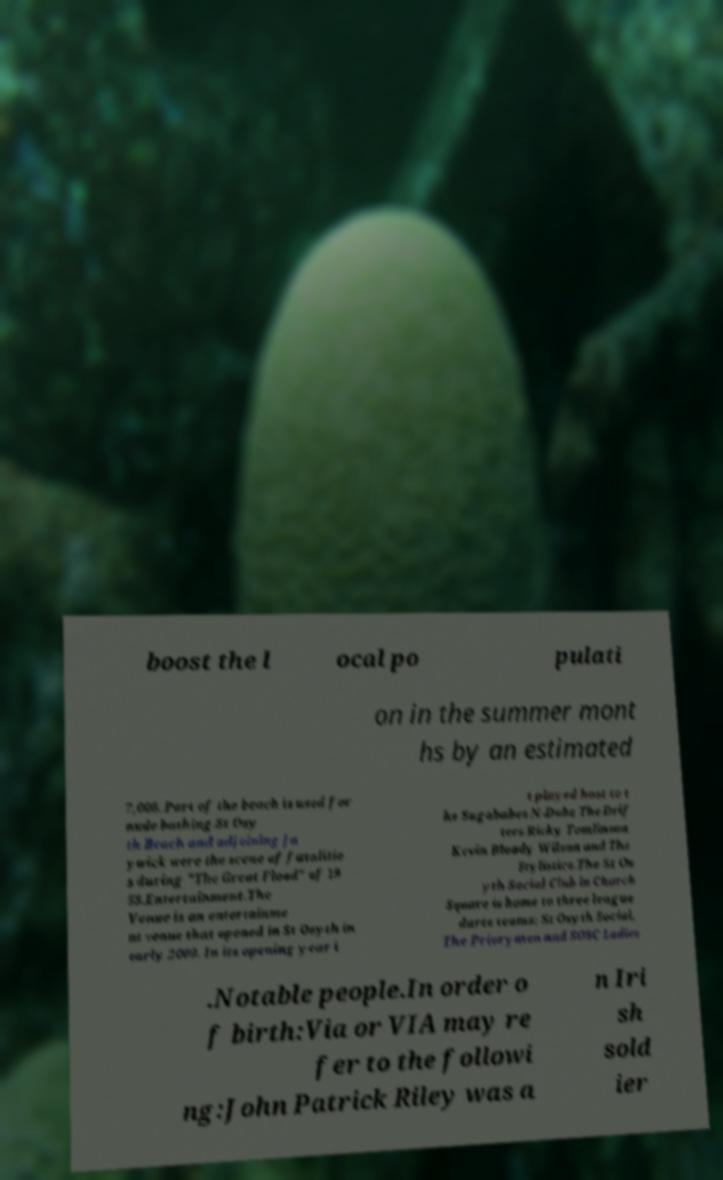Please identify and transcribe the text found in this image. boost the l ocal po pulati on in the summer mont hs by an estimated 7,000. Part of the beach is used for nude bathing.St Osy th Beach and adjoining Ja ywick were the scene of fatalitie s during "The Great Flood" of 19 53.Entertainment.The Venue is an entertainme nt venue that opened in St Osyth in early 2009. In its opening year i t played host to t he Sugababes N-Dubz The Drif ters Ricky Tomlinson Kevin Bloody Wilson and The Stylistics.The St Os yth Social Club in Church Square is home to three league darts teams: St Osyth Social, The Priorymen and SOSC Ladies .Notable people.In order o f birth:Via or VIA may re fer to the followi ng:John Patrick Riley was a n Iri sh sold ier 